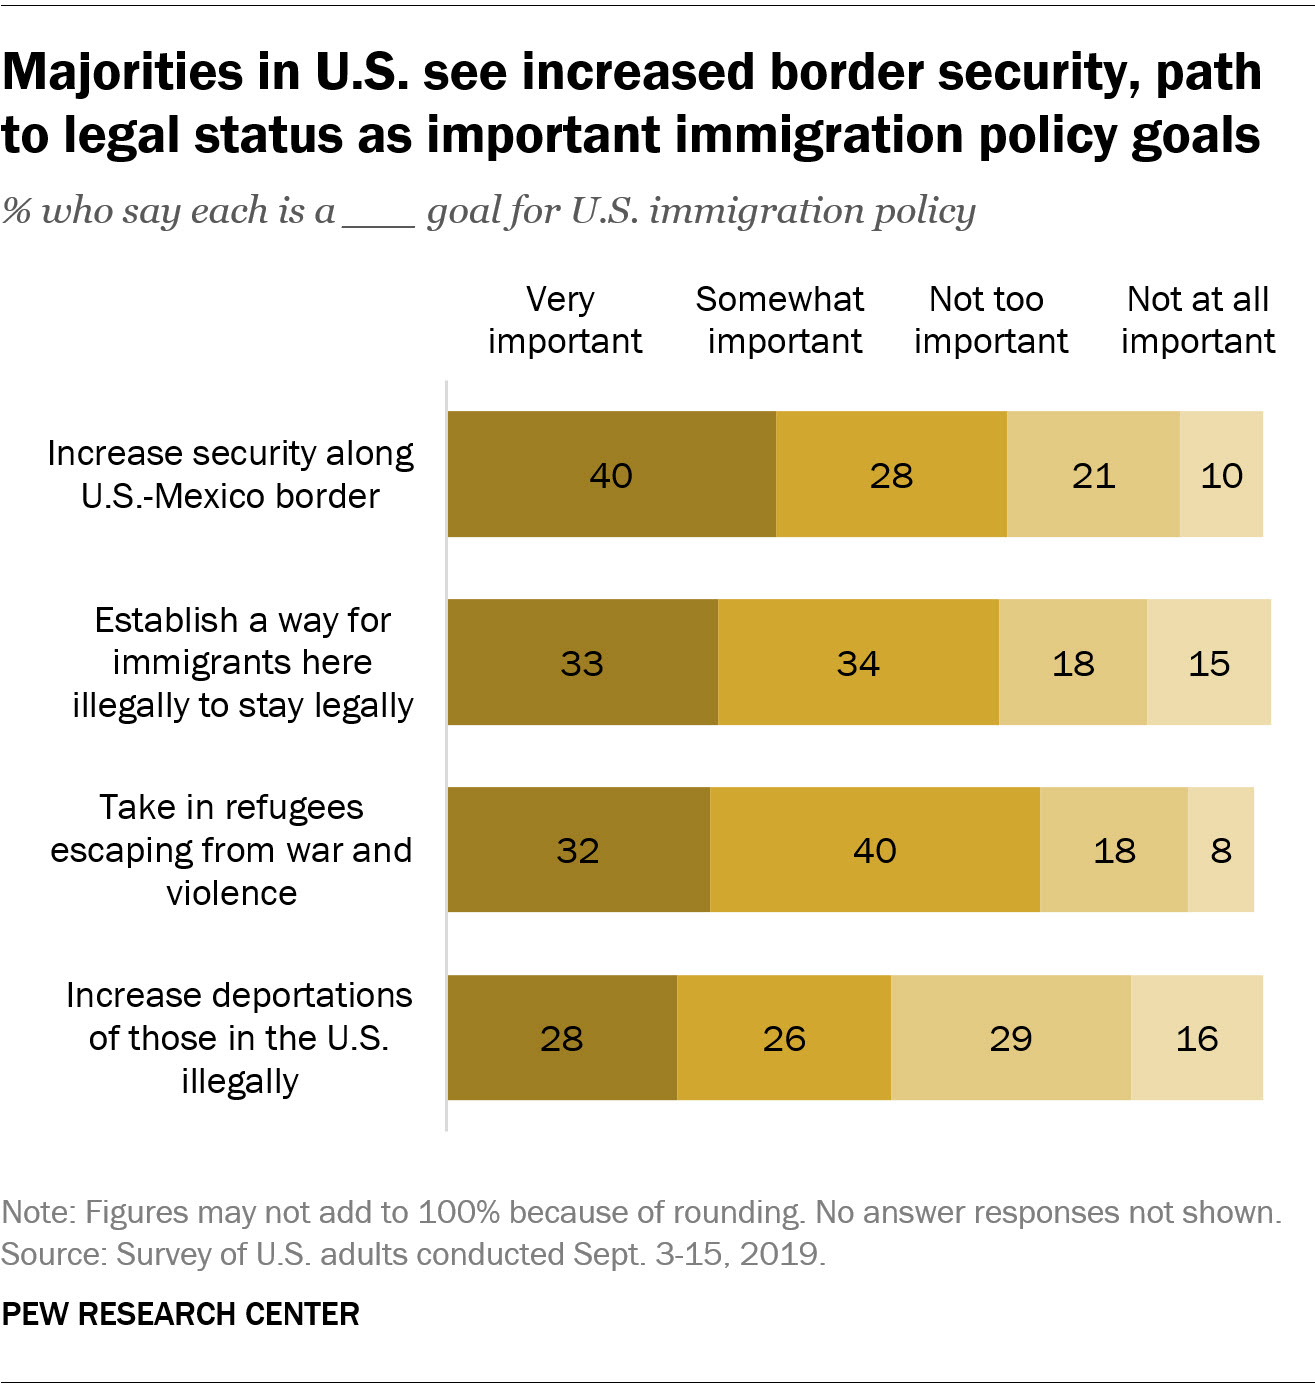Mention a couple of crucial points in this snapshot. Sixty-eight percent of people believe it is important to increase security along the US and Mexico border. According to a recent survey, a significant proportion of people believe that it is crucial to provide refuge to those fleeing war and violence, with 42% expressing this viewpoint. 